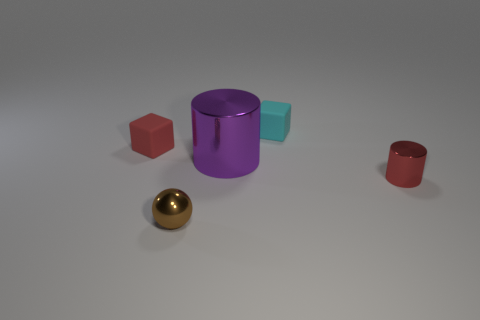Add 3 red metal cubes. How many objects exist? 8 Subtract all blocks. How many objects are left? 3 Add 3 purple metallic cylinders. How many purple metallic cylinders are left? 4 Add 2 large gray shiny cylinders. How many large gray shiny cylinders exist? 2 Subtract 1 red blocks. How many objects are left? 4 Subtract 2 cubes. How many cubes are left? 0 Subtract all purple balls. Subtract all yellow cylinders. How many balls are left? 1 Subtract all green balls. How many red cubes are left? 1 Subtract all small red objects. Subtract all cyan blocks. How many objects are left? 2 